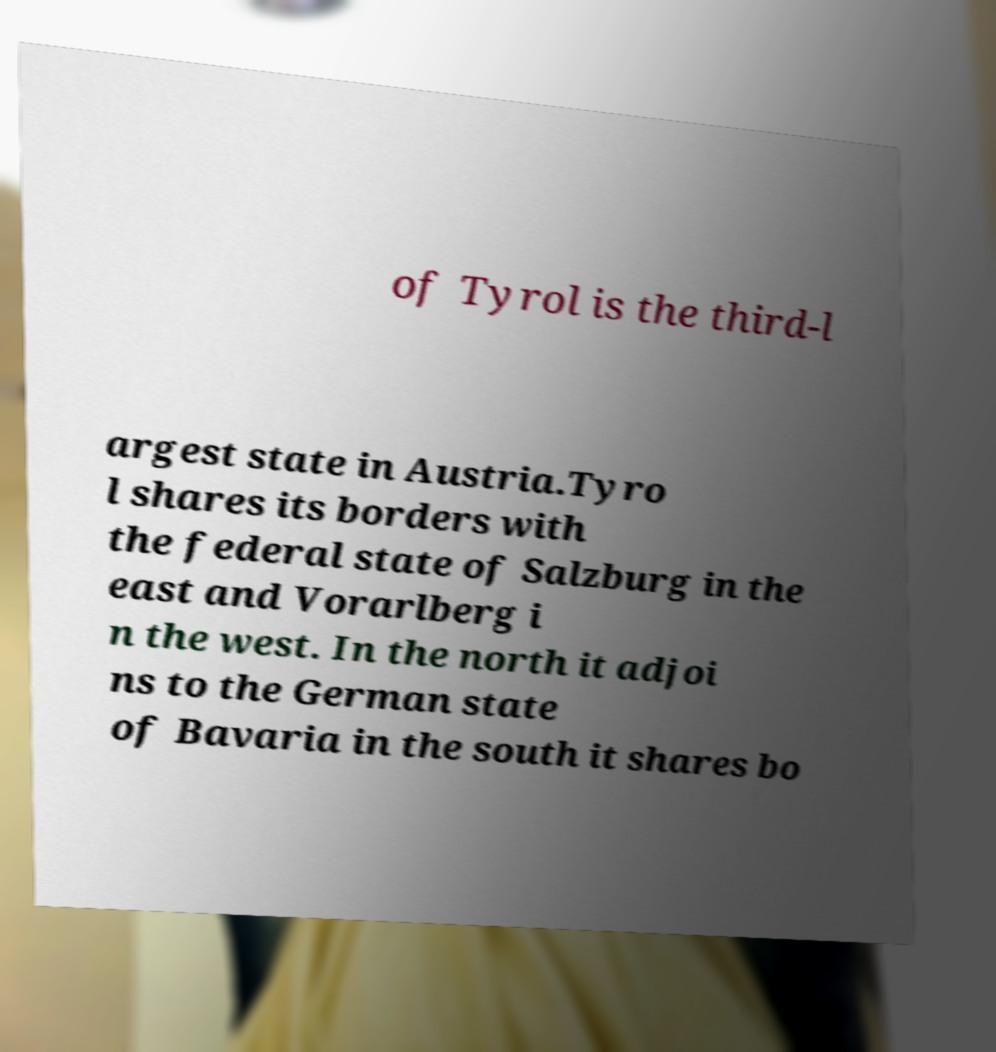Please read and relay the text visible in this image. What does it say? of Tyrol is the third-l argest state in Austria.Tyro l shares its borders with the federal state of Salzburg in the east and Vorarlberg i n the west. In the north it adjoi ns to the German state of Bavaria in the south it shares bo 